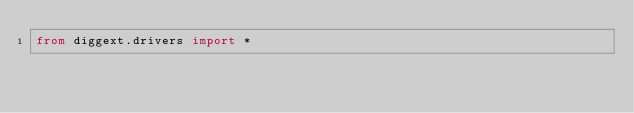Convert code to text. <code><loc_0><loc_0><loc_500><loc_500><_Python_>from diggext.drivers import *
</code> 